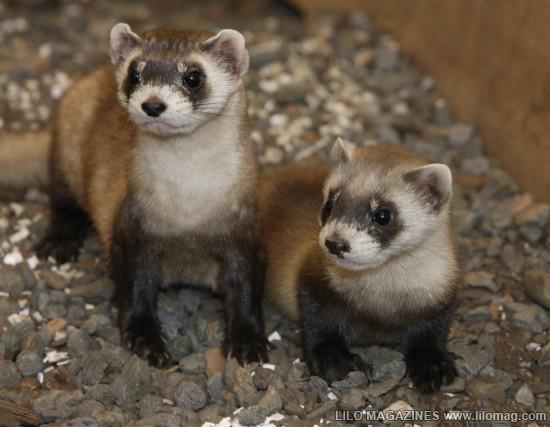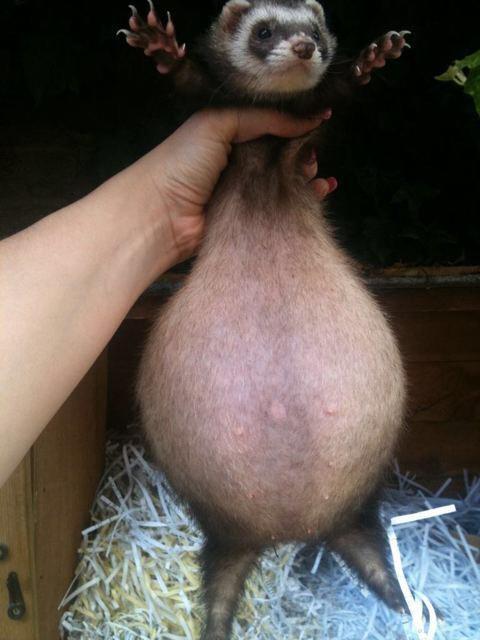The first image is the image on the left, the second image is the image on the right. For the images displayed, is the sentence "One image shows a single ferret with all its feet off the ground and its face forward." factually correct? Answer yes or no. Yes. The first image is the image on the left, the second image is the image on the right. For the images shown, is this caption "there are two ferrets standing on sandy dirt in the image pair" true? Answer yes or no. No. 